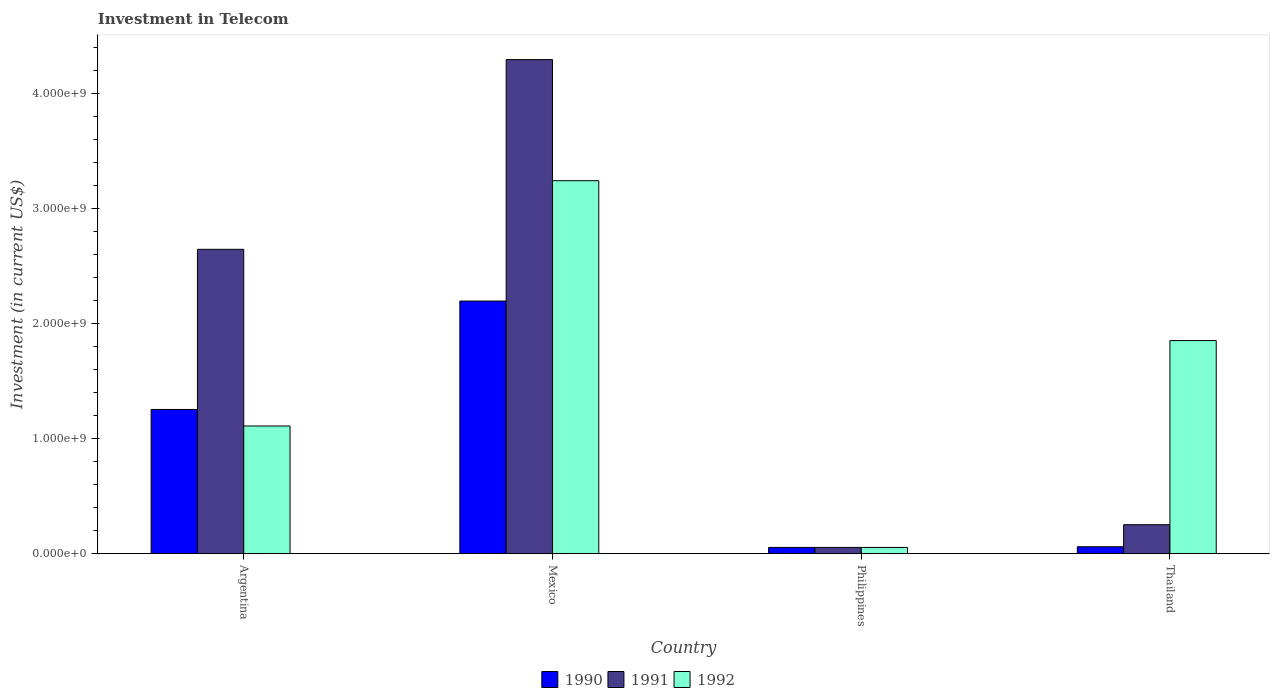How many bars are there on the 3rd tick from the right?
Your answer should be compact. 3. In how many cases, is the number of bars for a given country not equal to the number of legend labels?
Provide a short and direct response. 0. What is the amount invested in telecom in 1991 in Mexico?
Offer a terse response. 4.30e+09. Across all countries, what is the maximum amount invested in telecom in 1991?
Give a very brief answer. 4.30e+09. Across all countries, what is the minimum amount invested in telecom in 1992?
Offer a terse response. 5.42e+07. In which country was the amount invested in telecom in 1991 maximum?
Your response must be concise. Mexico. What is the total amount invested in telecom in 1991 in the graph?
Provide a succinct answer. 7.25e+09. What is the difference between the amount invested in telecom in 1990 in Argentina and that in Philippines?
Offer a very short reply. 1.20e+09. What is the difference between the amount invested in telecom in 1992 in Thailand and the amount invested in telecom in 1991 in Argentina?
Give a very brief answer. -7.94e+08. What is the average amount invested in telecom in 1991 per country?
Keep it short and to the point. 1.81e+09. What is the difference between the amount invested in telecom of/in 1991 and amount invested in telecom of/in 1992 in Argentina?
Provide a succinct answer. 1.54e+09. What is the ratio of the amount invested in telecom in 1992 in Philippines to that in Thailand?
Make the answer very short. 0.03. Is the difference between the amount invested in telecom in 1991 in Argentina and Thailand greater than the difference between the amount invested in telecom in 1992 in Argentina and Thailand?
Ensure brevity in your answer.  Yes. What is the difference between the highest and the second highest amount invested in telecom in 1990?
Your answer should be very brief. 2.14e+09. What is the difference between the highest and the lowest amount invested in telecom in 1991?
Your response must be concise. 4.24e+09. What does the 1st bar from the right in Mexico represents?
Ensure brevity in your answer.  1992. How many bars are there?
Your answer should be very brief. 12. Are all the bars in the graph horizontal?
Ensure brevity in your answer.  No. How many countries are there in the graph?
Give a very brief answer. 4. Are the values on the major ticks of Y-axis written in scientific E-notation?
Provide a short and direct response. Yes. What is the title of the graph?
Provide a succinct answer. Investment in Telecom. What is the label or title of the Y-axis?
Ensure brevity in your answer.  Investment (in current US$). What is the Investment (in current US$) in 1990 in Argentina?
Give a very brief answer. 1.25e+09. What is the Investment (in current US$) of 1991 in Argentina?
Your response must be concise. 2.65e+09. What is the Investment (in current US$) in 1992 in Argentina?
Your answer should be compact. 1.11e+09. What is the Investment (in current US$) in 1990 in Mexico?
Offer a terse response. 2.20e+09. What is the Investment (in current US$) of 1991 in Mexico?
Ensure brevity in your answer.  4.30e+09. What is the Investment (in current US$) in 1992 in Mexico?
Provide a short and direct response. 3.24e+09. What is the Investment (in current US$) of 1990 in Philippines?
Ensure brevity in your answer.  5.42e+07. What is the Investment (in current US$) of 1991 in Philippines?
Offer a very short reply. 5.42e+07. What is the Investment (in current US$) in 1992 in Philippines?
Make the answer very short. 5.42e+07. What is the Investment (in current US$) of 1990 in Thailand?
Keep it short and to the point. 6.00e+07. What is the Investment (in current US$) of 1991 in Thailand?
Your answer should be very brief. 2.52e+08. What is the Investment (in current US$) in 1992 in Thailand?
Provide a short and direct response. 1.85e+09. Across all countries, what is the maximum Investment (in current US$) of 1990?
Provide a succinct answer. 2.20e+09. Across all countries, what is the maximum Investment (in current US$) of 1991?
Provide a succinct answer. 4.30e+09. Across all countries, what is the maximum Investment (in current US$) of 1992?
Make the answer very short. 3.24e+09. Across all countries, what is the minimum Investment (in current US$) in 1990?
Give a very brief answer. 5.42e+07. Across all countries, what is the minimum Investment (in current US$) in 1991?
Your answer should be very brief. 5.42e+07. Across all countries, what is the minimum Investment (in current US$) of 1992?
Your answer should be compact. 5.42e+07. What is the total Investment (in current US$) of 1990 in the graph?
Offer a very short reply. 3.57e+09. What is the total Investment (in current US$) in 1991 in the graph?
Ensure brevity in your answer.  7.25e+09. What is the total Investment (in current US$) in 1992 in the graph?
Your response must be concise. 6.26e+09. What is the difference between the Investment (in current US$) of 1990 in Argentina and that in Mexico?
Your answer should be compact. -9.43e+08. What is the difference between the Investment (in current US$) of 1991 in Argentina and that in Mexico?
Provide a short and direct response. -1.65e+09. What is the difference between the Investment (in current US$) of 1992 in Argentina and that in Mexico?
Offer a terse response. -2.13e+09. What is the difference between the Investment (in current US$) in 1990 in Argentina and that in Philippines?
Offer a very short reply. 1.20e+09. What is the difference between the Investment (in current US$) of 1991 in Argentina and that in Philippines?
Provide a short and direct response. 2.59e+09. What is the difference between the Investment (in current US$) of 1992 in Argentina and that in Philippines?
Make the answer very short. 1.06e+09. What is the difference between the Investment (in current US$) of 1990 in Argentina and that in Thailand?
Offer a very short reply. 1.19e+09. What is the difference between the Investment (in current US$) in 1991 in Argentina and that in Thailand?
Keep it short and to the point. 2.40e+09. What is the difference between the Investment (in current US$) of 1992 in Argentina and that in Thailand?
Give a very brief answer. -7.43e+08. What is the difference between the Investment (in current US$) in 1990 in Mexico and that in Philippines?
Your answer should be compact. 2.14e+09. What is the difference between the Investment (in current US$) in 1991 in Mexico and that in Philippines?
Ensure brevity in your answer.  4.24e+09. What is the difference between the Investment (in current US$) in 1992 in Mexico and that in Philippines?
Ensure brevity in your answer.  3.19e+09. What is the difference between the Investment (in current US$) in 1990 in Mexico and that in Thailand?
Provide a short and direct response. 2.14e+09. What is the difference between the Investment (in current US$) of 1991 in Mexico and that in Thailand?
Offer a very short reply. 4.05e+09. What is the difference between the Investment (in current US$) in 1992 in Mexico and that in Thailand?
Give a very brief answer. 1.39e+09. What is the difference between the Investment (in current US$) of 1990 in Philippines and that in Thailand?
Make the answer very short. -5.80e+06. What is the difference between the Investment (in current US$) in 1991 in Philippines and that in Thailand?
Your response must be concise. -1.98e+08. What is the difference between the Investment (in current US$) in 1992 in Philippines and that in Thailand?
Offer a terse response. -1.80e+09. What is the difference between the Investment (in current US$) of 1990 in Argentina and the Investment (in current US$) of 1991 in Mexico?
Your answer should be compact. -3.04e+09. What is the difference between the Investment (in current US$) in 1990 in Argentina and the Investment (in current US$) in 1992 in Mexico?
Give a very brief answer. -1.99e+09. What is the difference between the Investment (in current US$) in 1991 in Argentina and the Investment (in current US$) in 1992 in Mexico?
Provide a short and direct response. -5.97e+08. What is the difference between the Investment (in current US$) of 1990 in Argentina and the Investment (in current US$) of 1991 in Philippines?
Ensure brevity in your answer.  1.20e+09. What is the difference between the Investment (in current US$) of 1990 in Argentina and the Investment (in current US$) of 1992 in Philippines?
Ensure brevity in your answer.  1.20e+09. What is the difference between the Investment (in current US$) of 1991 in Argentina and the Investment (in current US$) of 1992 in Philippines?
Offer a very short reply. 2.59e+09. What is the difference between the Investment (in current US$) in 1990 in Argentina and the Investment (in current US$) in 1991 in Thailand?
Give a very brief answer. 1.00e+09. What is the difference between the Investment (in current US$) of 1990 in Argentina and the Investment (in current US$) of 1992 in Thailand?
Keep it short and to the point. -5.99e+08. What is the difference between the Investment (in current US$) in 1991 in Argentina and the Investment (in current US$) in 1992 in Thailand?
Make the answer very short. 7.94e+08. What is the difference between the Investment (in current US$) in 1990 in Mexico and the Investment (in current US$) in 1991 in Philippines?
Your answer should be compact. 2.14e+09. What is the difference between the Investment (in current US$) of 1990 in Mexico and the Investment (in current US$) of 1992 in Philippines?
Provide a succinct answer. 2.14e+09. What is the difference between the Investment (in current US$) in 1991 in Mexico and the Investment (in current US$) in 1992 in Philippines?
Ensure brevity in your answer.  4.24e+09. What is the difference between the Investment (in current US$) of 1990 in Mexico and the Investment (in current US$) of 1991 in Thailand?
Make the answer very short. 1.95e+09. What is the difference between the Investment (in current US$) in 1990 in Mexico and the Investment (in current US$) in 1992 in Thailand?
Your answer should be compact. 3.44e+08. What is the difference between the Investment (in current US$) in 1991 in Mexico and the Investment (in current US$) in 1992 in Thailand?
Ensure brevity in your answer.  2.44e+09. What is the difference between the Investment (in current US$) in 1990 in Philippines and the Investment (in current US$) in 1991 in Thailand?
Keep it short and to the point. -1.98e+08. What is the difference between the Investment (in current US$) in 1990 in Philippines and the Investment (in current US$) in 1992 in Thailand?
Your answer should be compact. -1.80e+09. What is the difference between the Investment (in current US$) of 1991 in Philippines and the Investment (in current US$) of 1992 in Thailand?
Give a very brief answer. -1.80e+09. What is the average Investment (in current US$) in 1990 per country?
Provide a short and direct response. 8.92e+08. What is the average Investment (in current US$) of 1991 per country?
Your answer should be very brief. 1.81e+09. What is the average Investment (in current US$) of 1992 per country?
Offer a very short reply. 1.57e+09. What is the difference between the Investment (in current US$) in 1990 and Investment (in current US$) in 1991 in Argentina?
Ensure brevity in your answer.  -1.39e+09. What is the difference between the Investment (in current US$) in 1990 and Investment (in current US$) in 1992 in Argentina?
Keep it short and to the point. 1.44e+08. What is the difference between the Investment (in current US$) of 1991 and Investment (in current US$) of 1992 in Argentina?
Your answer should be compact. 1.54e+09. What is the difference between the Investment (in current US$) in 1990 and Investment (in current US$) in 1991 in Mexico?
Give a very brief answer. -2.10e+09. What is the difference between the Investment (in current US$) in 1990 and Investment (in current US$) in 1992 in Mexico?
Your answer should be very brief. -1.05e+09. What is the difference between the Investment (in current US$) of 1991 and Investment (in current US$) of 1992 in Mexico?
Make the answer very short. 1.05e+09. What is the difference between the Investment (in current US$) of 1990 and Investment (in current US$) of 1991 in Philippines?
Offer a terse response. 0. What is the difference between the Investment (in current US$) in 1990 and Investment (in current US$) in 1992 in Philippines?
Give a very brief answer. 0. What is the difference between the Investment (in current US$) in 1990 and Investment (in current US$) in 1991 in Thailand?
Keep it short and to the point. -1.92e+08. What is the difference between the Investment (in current US$) of 1990 and Investment (in current US$) of 1992 in Thailand?
Your answer should be very brief. -1.79e+09. What is the difference between the Investment (in current US$) in 1991 and Investment (in current US$) in 1992 in Thailand?
Provide a short and direct response. -1.60e+09. What is the ratio of the Investment (in current US$) in 1990 in Argentina to that in Mexico?
Give a very brief answer. 0.57. What is the ratio of the Investment (in current US$) of 1991 in Argentina to that in Mexico?
Provide a short and direct response. 0.62. What is the ratio of the Investment (in current US$) in 1992 in Argentina to that in Mexico?
Your response must be concise. 0.34. What is the ratio of the Investment (in current US$) in 1990 in Argentina to that in Philippines?
Keep it short and to the point. 23.15. What is the ratio of the Investment (in current US$) of 1991 in Argentina to that in Philippines?
Provide a succinct answer. 48.86. What is the ratio of the Investment (in current US$) of 1992 in Argentina to that in Philippines?
Your response must be concise. 20.5. What is the ratio of the Investment (in current US$) of 1990 in Argentina to that in Thailand?
Your answer should be very brief. 20.91. What is the ratio of the Investment (in current US$) in 1991 in Argentina to that in Thailand?
Your response must be concise. 10.51. What is the ratio of the Investment (in current US$) in 1992 in Argentina to that in Thailand?
Make the answer very short. 0.6. What is the ratio of the Investment (in current US$) of 1990 in Mexico to that in Philippines?
Your answer should be very brief. 40.55. What is the ratio of the Investment (in current US$) in 1991 in Mexico to that in Philippines?
Give a very brief answer. 79.32. What is the ratio of the Investment (in current US$) in 1992 in Mexico to that in Philippines?
Your answer should be compact. 59.87. What is the ratio of the Investment (in current US$) in 1990 in Mexico to that in Thailand?
Make the answer very short. 36.63. What is the ratio of the Investment (in current US$) of 1991 in Mexico to that in Thailand?
Ensure brevity in your answer.  17.06. What is the ratio of the Investment (in current US$) in 1992 in Mexico to that in Thailand?
Offer a terse response. 1.75. What is the ratio of the Investment (in current US$) of 1990 in Philippines to that in Thailand?
Provide a succinct answer. 0.9. What is the ratio of the Investment (in current US$) of 1991 in Philippines to that in Thailand?
Provide a short and direct response. 0.22. What is the ratio of the Investment (in current US$) of 1992 in Philippines to that in Thailand?
Make the answer very short. 0.03. What is the difference between the highest and the second highest Investment (in current US$) of 1990?
Make the answer very short. 9.43e+08. What is the difference between the highest and the second highest Investment (in current US$) in 1991?
Provide a short and direct response. 1.65e+09. What is the difference between the highest and the second highest Investment (in current US$) of 1992?
Make the answer very short. 1.39e+09. What is the difference between the highest and the lowest Investment (in current US$) of 1990?
Keep it short and to the point. 2.14e+09. What is the difference between the highest and the lowest Investment (in current US$) in 1991?
Give a very brief answer. 4.24e+09. What is the difference between the highest and the lowest Investment (in current US$) in 1992?
Keep it short and to the point. 3.19e+09. 